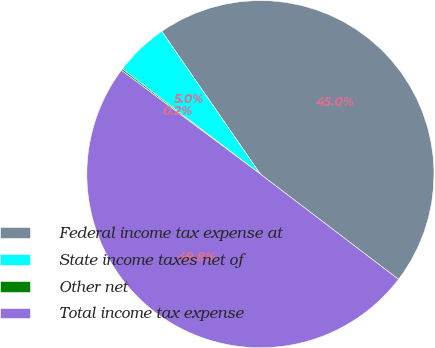Convert chart. <chart><loc_0><loc_0><loc_500><loc_500><pie_chart><fcel>Federal income tax expense at<fcel>State income taxes net of<fcel>Other net<fcel>Total income tax expense<nl><fcel>44.98%<fcel>5.02%<fcel>0.15%<fcel>49.85%<nl></chart> 